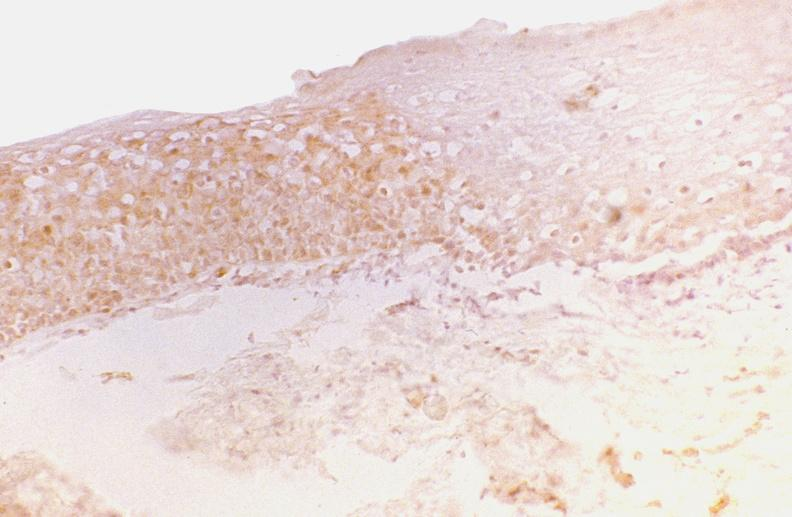where is this from?
Answer the question using a single word or phrase. Gastrointestinal system 